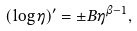<formula> <loc_0><loc_0><loc_500><loc_500>( \log \eta ) ^ { \prime } = \pm B \eta ^ { \beta - 1 } ,</formula> 